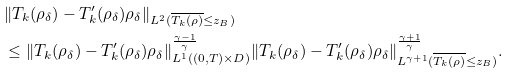<formula> <loc_0><loc_0><loc_500><loc_500>& \| T _ { k } ( \rho _ { \delta } ) - T ^ { \prime } _ { k } ( \rho _ { \delta } ) \rho _ { \delta } \| _ { L ^ { 2 } ( { \overline { T _ { k } ( \rho ) } \leq z _ { B } } ) } \\ & \leq \| T _ { k } ( \rho _ { \delta } ) - T ^ { \prime } _ { k } ( \rho _ { \delta } ) \rho _ { \delta } \| ^ { \frac { \gamma - 1 } { \gamma } } _ { L ^ { 1 } ( ( 0 , T ) \times D ) } \| T _ { k } ( \rho _ { \delta } ) - T ^ { \prime } _ { k } ( \rho _ { \delta } ) \rho _ { \delta } \| ^ { \frac { \gamma + 1 } { \gamma } } _ { L ^ { \gamma + 1 } ( { \overline { T _ { k } ( \rho ) } \leq z _ { B } } ) } .</formula> 